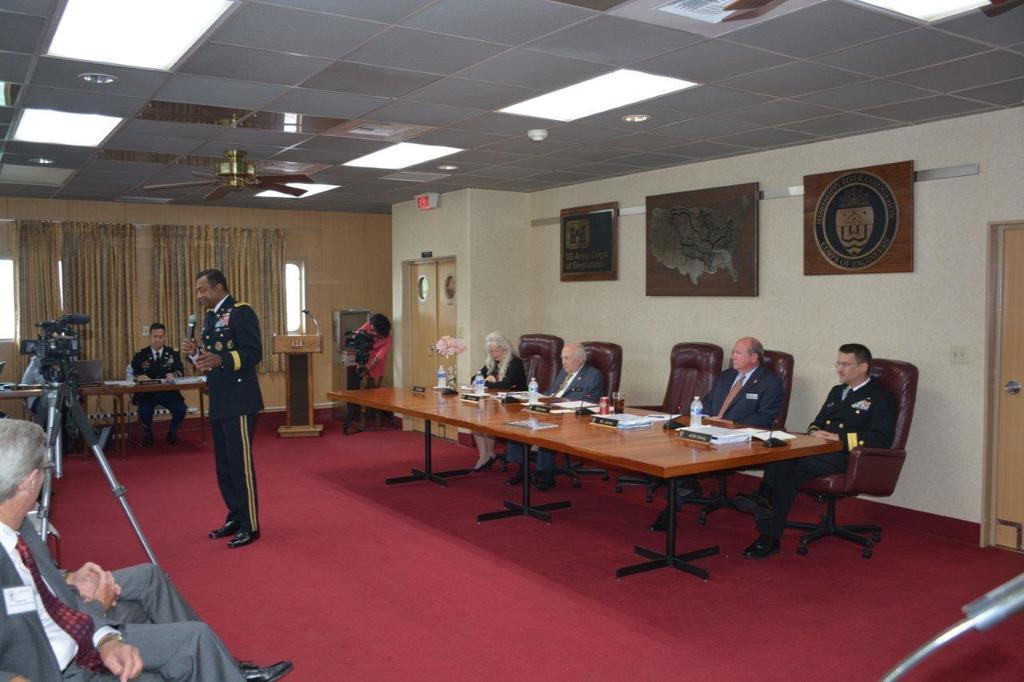Please provide a concise description of this image. In this picture we can see a group of people siting on chairs and in front of them on table we have bottles, tins, glasses, books, vase with flower in it and in middle person holding mic in his hand and talking and in background we can see curtains, door, frames, podium with mic, camera. 